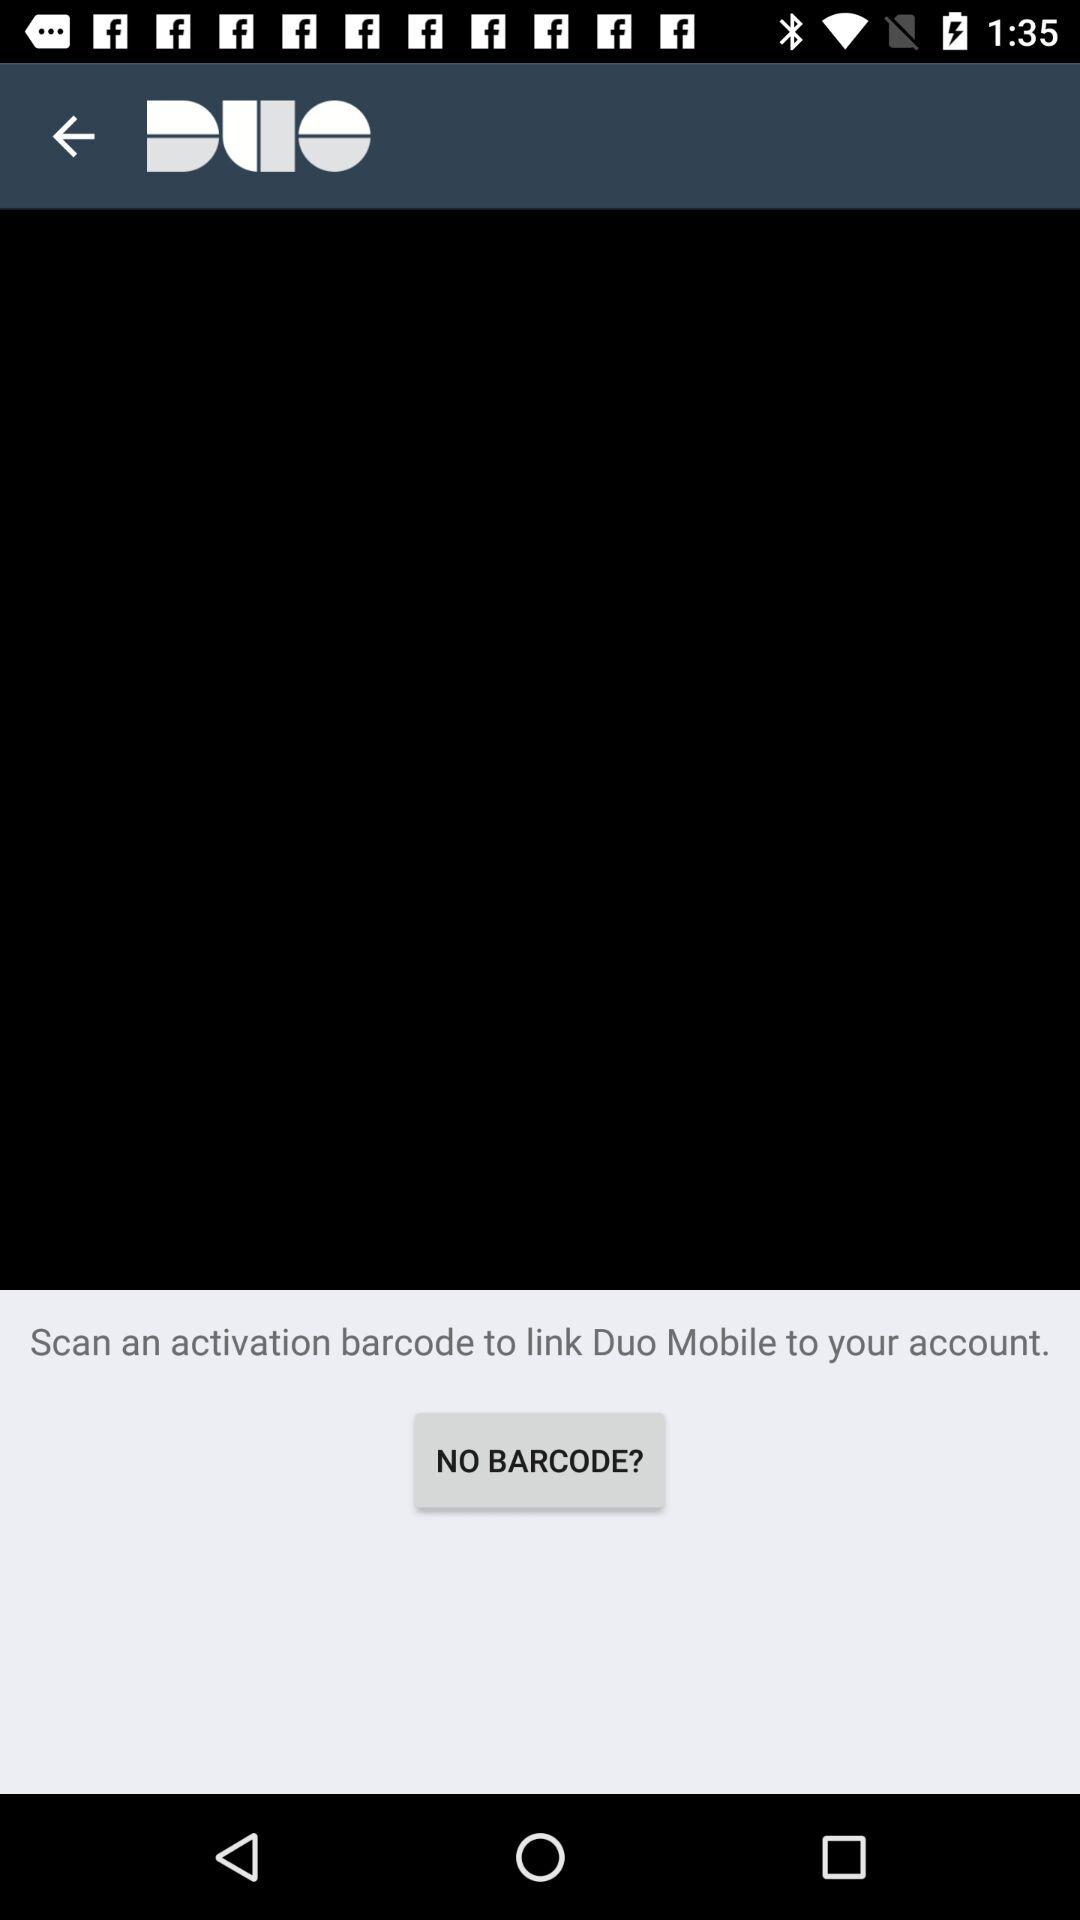What is the name of the application? The name of the application is "Duo". 